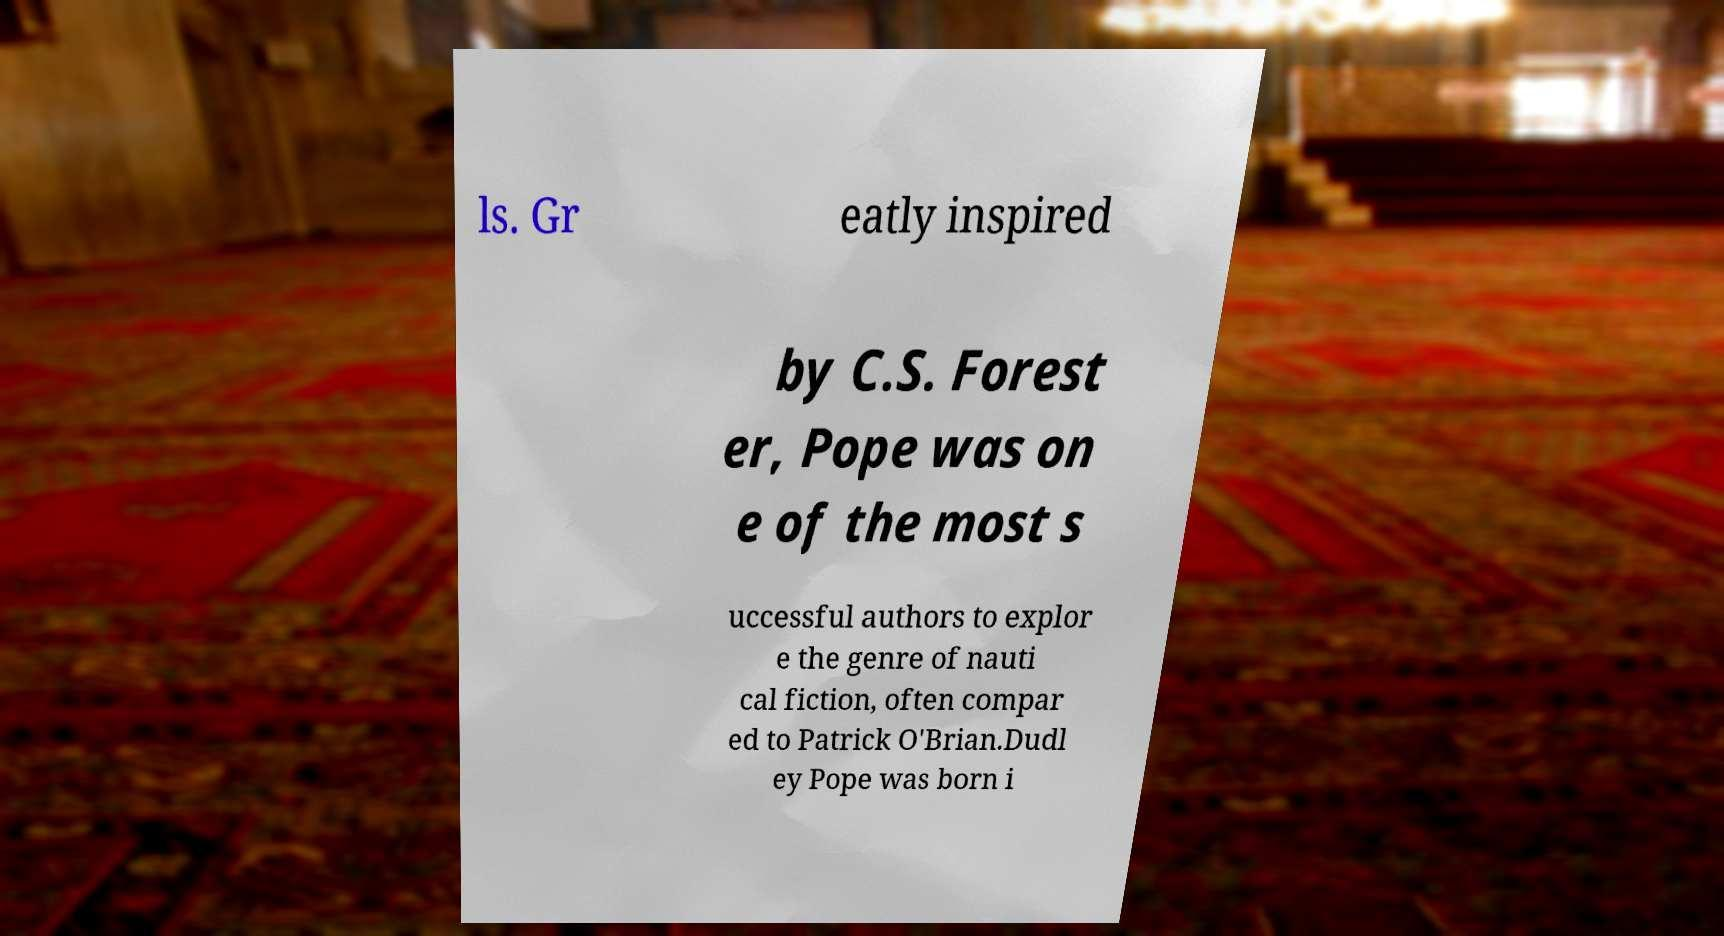I need the written content from this picture converted into text. Can you do that? ls. Gr eatly inspired by C.S. Forest er, Pope was on e of the most s uccessful authors to explor e the genre of nauti cal fiction, often compar ed to Patrick O'Brian.Dudl ey Pope was born i 